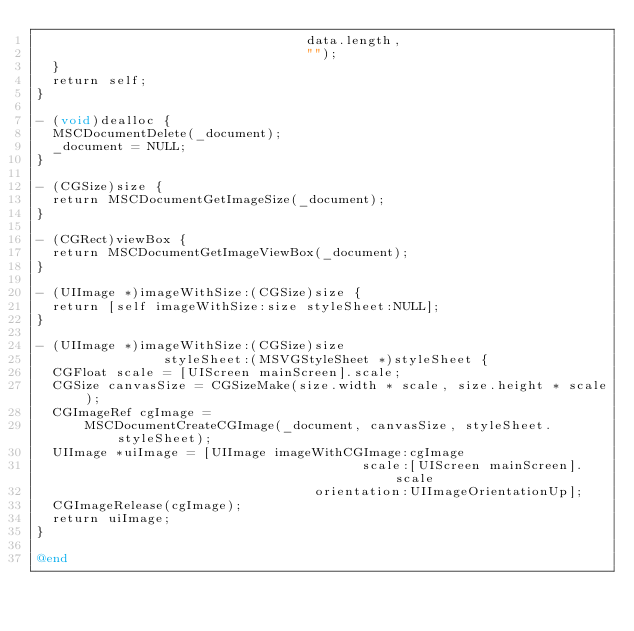<code> <loc_0><loc_0><loc_500><loc_500><_ObjectiveC_>                                  data.length,
                                  "");
  }
  return self;
}

- (void)dealloc {
  MSCDocumentDelete(_document);
  _document = NULL;
}

- (CGSize)size {
  return MSCDocumentGetImageSize(_document);
}

- (CGRect)viewBox {
  return MSCDocumentGetImageViewBox(_document);
}

- (UIImage *)imageWithSize:(CGSize)size {
  return [self imageWithSize:size styleSheet:NULL];
}

- (UIImage *)imageWithSize:(CGSize)size
                styleSheet:(MSVGStyleSheet *)styleSheet {
  CGFloat scale = [UIScreen mainScreen].scale;
  CGSize canvasSize = CGSizeMake(size.width * scale, size.height * scale);
  CGImageRef cgImage =
      MSCDocumentCreateCGImage(_document, canvasSize, styleSheet.styleSheet);
  UIImage *uiImage = [UIImage imageWithCGImage:cgImage
                                         scale:[UIScreen mainScreen].scale
                                   orientation:UIImageOrientationUp];
  CGImageRelease(cgImage);
  return uiImage;
}

@end
</code> 